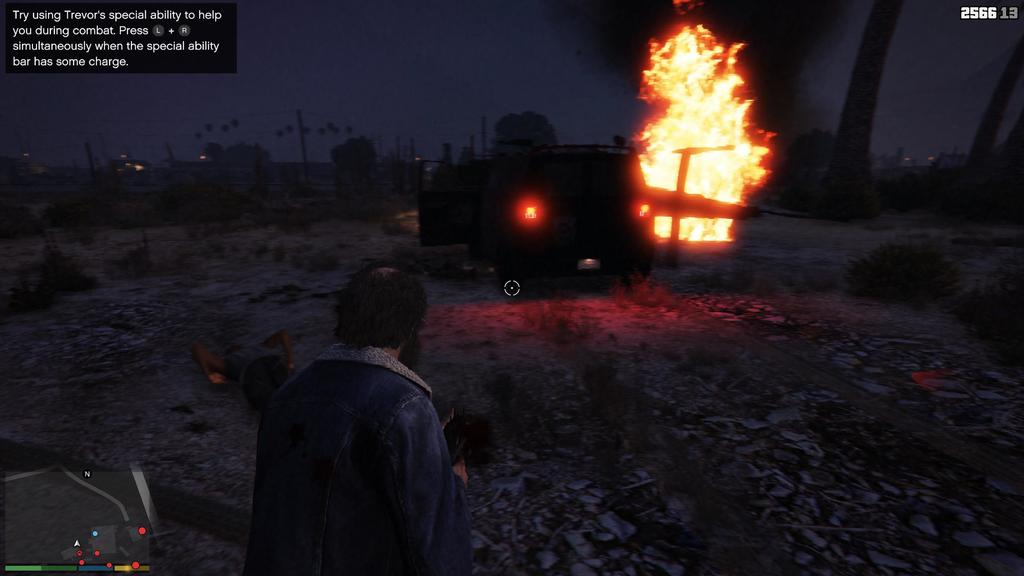What type of image is being described? The image is animated. Can you describe any characters or figures in the image? There is a man in the image. What object might be used for navigation or geographical reference in the image? There is a map in the image. What mode of transportation is present in the image? There is an air craft in the image. What type of natural environment is depicted in the image? There are trees in the image. What type of song is being sung by the trees in the image? There are no trees singing in the image; they are simply depicted as part of the natural environment. 